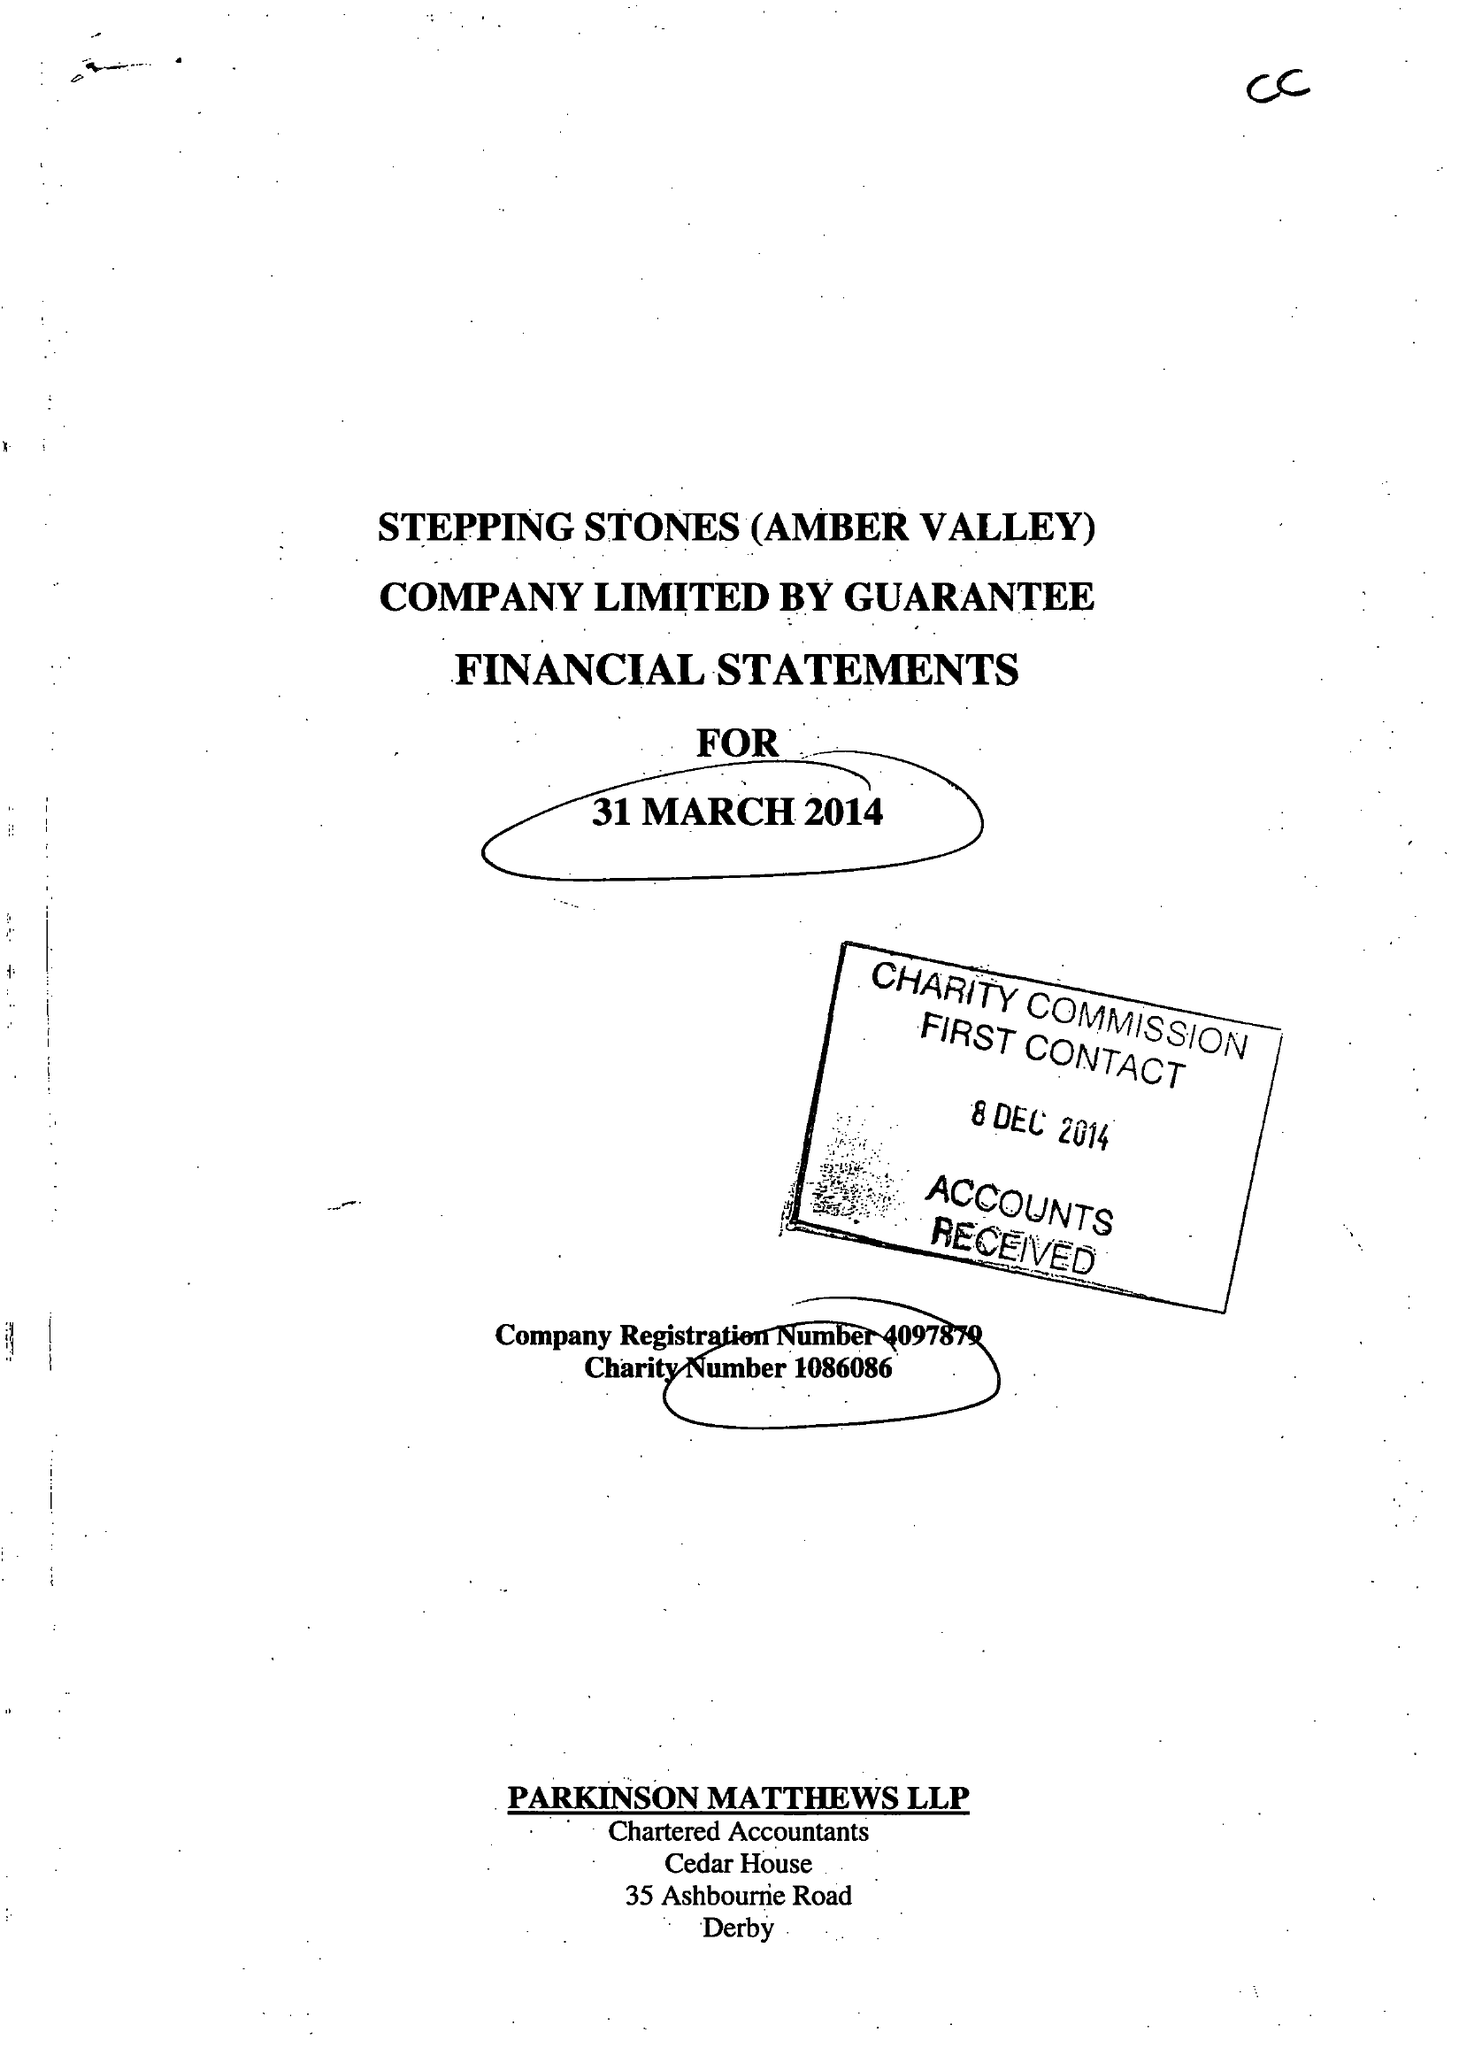What is the value for the charity_name?
Answer the question using a single word or phrase. Stepping Stones (Amber Valley) 